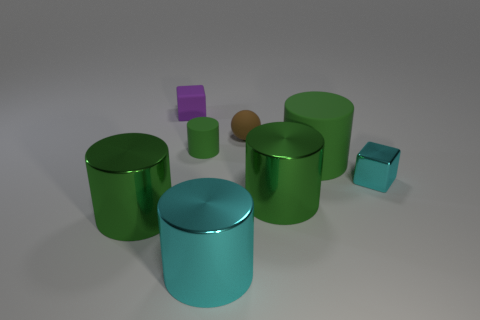How many green cylinders must be subtracted to get 2 green cylinders? 2 Subtract all yellow blocks. How many green cylinders are left? 4 Subtract 2 cylinders. How many cylinders are left? 3 Subtract all cyan cylinders. How many cylinders are left? 4 Subtract all brown cylinders. Subtract all cyan cubes. How many cylinders are left? 5 Add 1 tiny green objects. How many objects exist? 9 Subtract all cylinders. How many objects are left? 3 Subtract 0 gray blocks. How many objects are left? 8 Subtract all purple cubes. Subtract all large green matte objects. How many objects are left? 6 Add 8 tiny purple matte cubes. How many tiny purple matte cubes are left? 9 